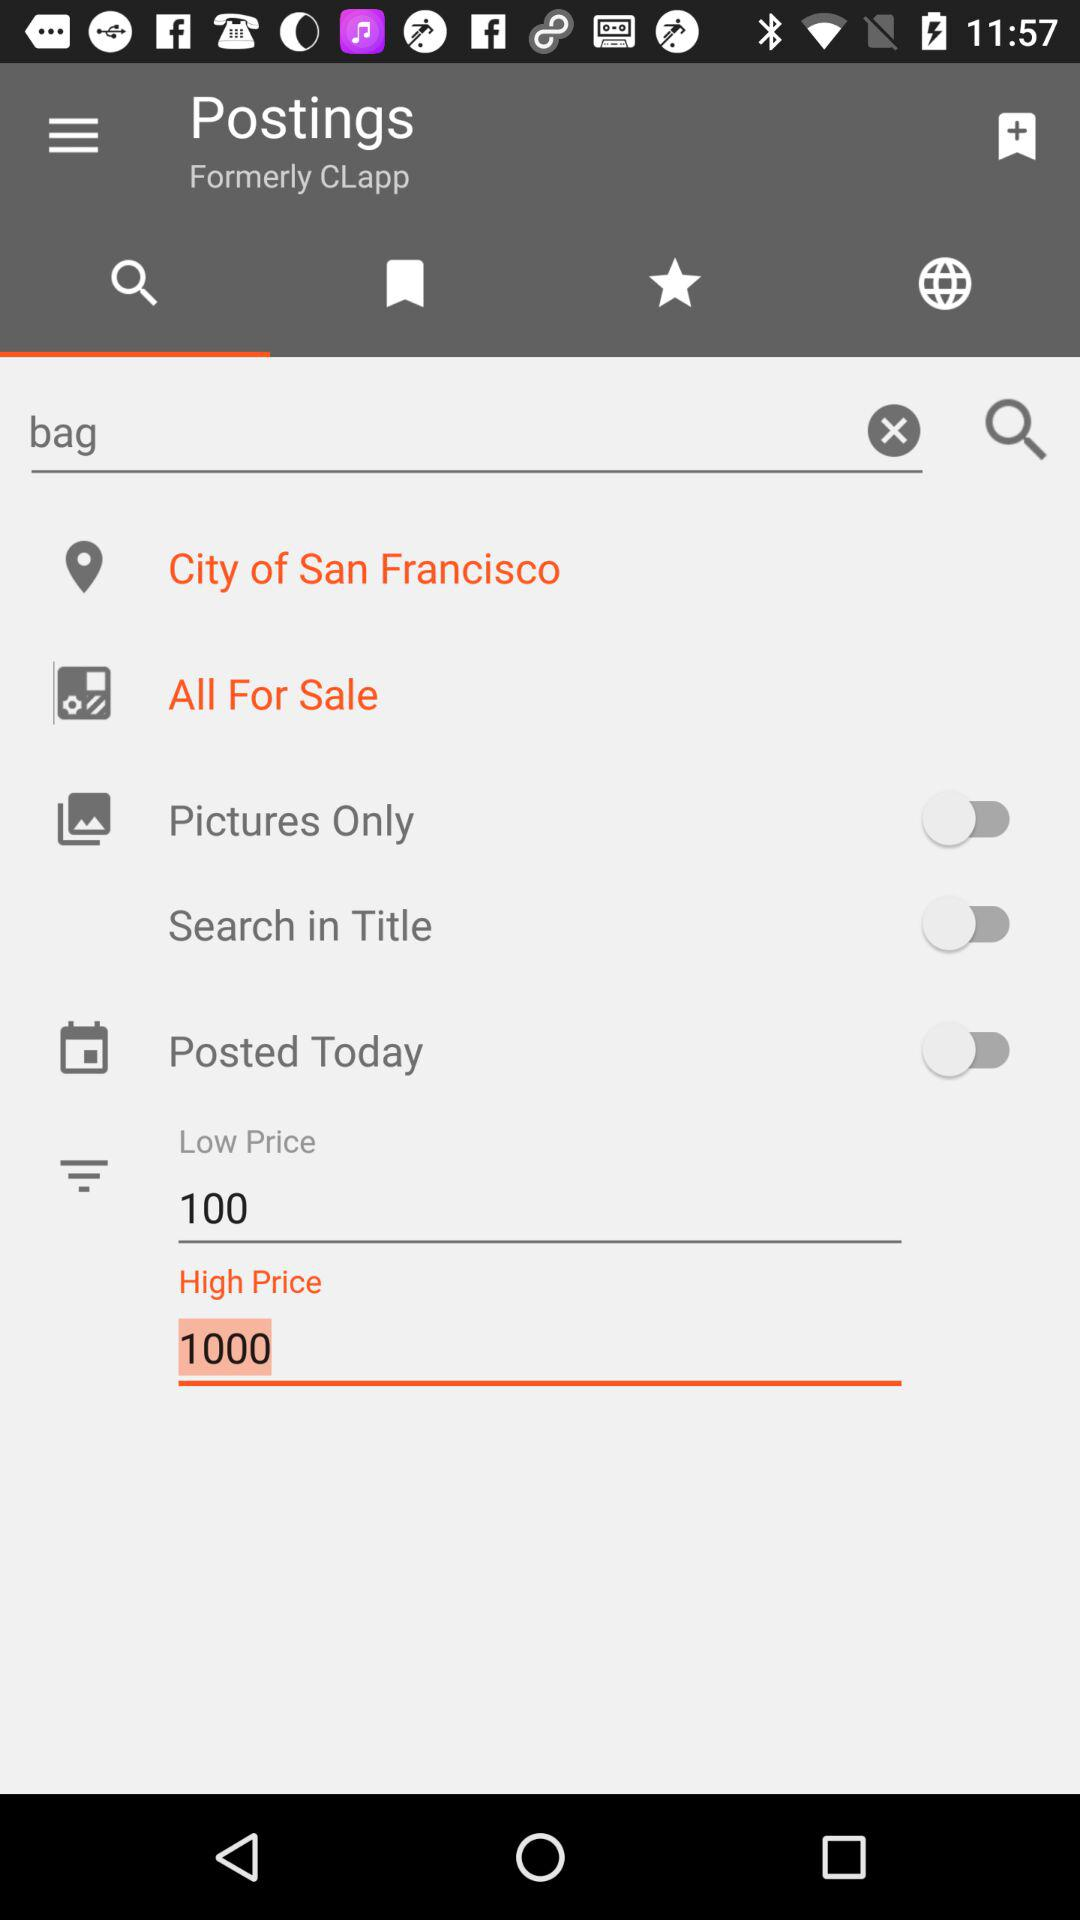What is the location? The location is San Francisco. 